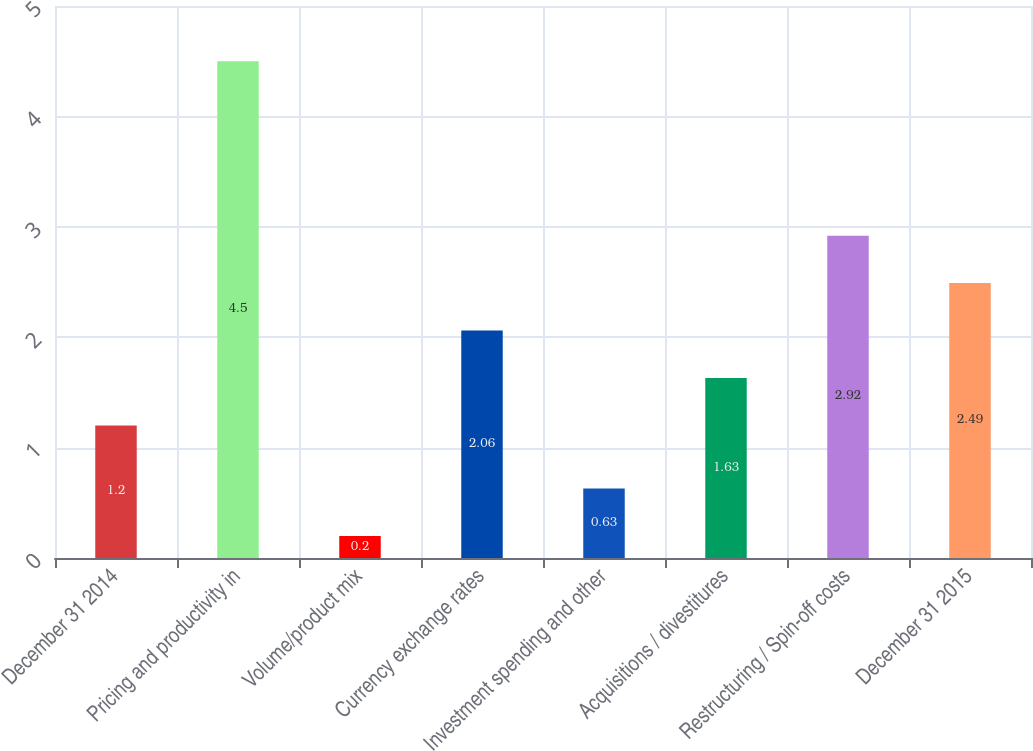Convert chart to OTSL. <chart><loc_0><loc_0><loc_500><loc_500><bar_chart><fcel>December 31 2014<fcel>Pricing and productivity in<fcel>Volume/product mix<fcel>Currency exchange rates<fcel>Investment spending and other<fcel>Acquisitions / divestitures<fcel>Restructuring / Spin-off costs<fcel>December 31 2015<nl><fcel>1.2<fcel>4.5<fcel>0.2<fcel>2.06<fcel>0.63<fcel>1.63<fcel>2.92<fcel>2.49<nl></chart> 